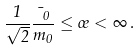Convert formula to latex. <formula><loc_0><loc_0><loc_500><loc_500>\frac { 1 } { \sqrt { 2 } } \frac { \mu _ { 0 } } { m _ { 0 } } \leq \sigma < \infty \, .</formula> 